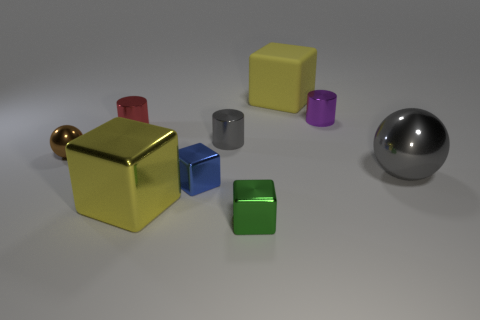Subtract all yellow cylinders. How many yellow cubes are left? 2 Subtract all matte cubes. How many cubes are left? 3 Subtract all green cubes. How many cubes are left? 3 Subtract 2 cubes. How many cubes are left? 2 Add 1 gray metallic spheres. How many objects exist? 10 Subtract all red cubes. Subtract all gray cylinders. How many cubes are left? 4 Subtract all cylinders. How many objects are left? 6 Add 6 matte cubes. How many matte cubes exist? 7 Subtract 0 cyan spheres. How many objects are left? 9 Subtract all big gray metal objects. Subtract all small red metallic cylinders. How many objects are left? 7 